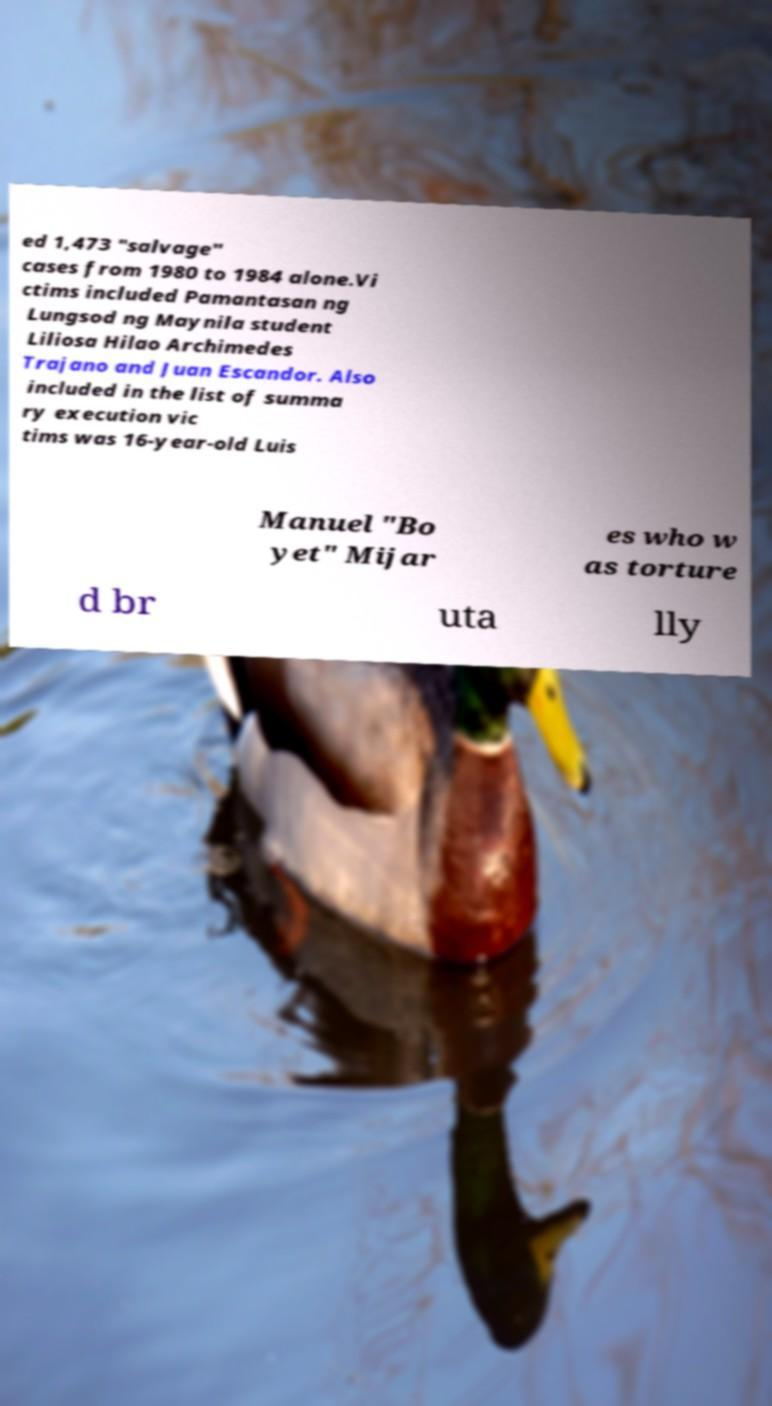Please identify and transcribe the text found in this image. ed 1,473 "salvage" cases from 1980 to 1984 alone.Vi ctims included Pamantasan ng Lungsod ng Maynila student Liliosa Hilao Archimedes Trajano and Juan Escandor. Also included in the list of summa ry execution vic tims was 16-year-old Luis Manuel "Bo yet" Mijar es who w as torture d br uta lly 